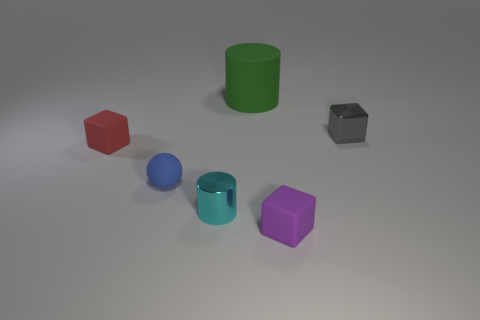Add 2 red shiny cylinders. How many objects exist? 8 Subtract all cylinders. How many objects are left? 4 Subtract all large cyan balls. Subtract all tiny metallic cylinders. How many objects are left? 5 Add 1 cylinders. How many cylinders are left? 3 Add 4 big yellow objects. How many big yellow objects exist? 4 Subtract 1 green cylinders. How many objects are left? 5 